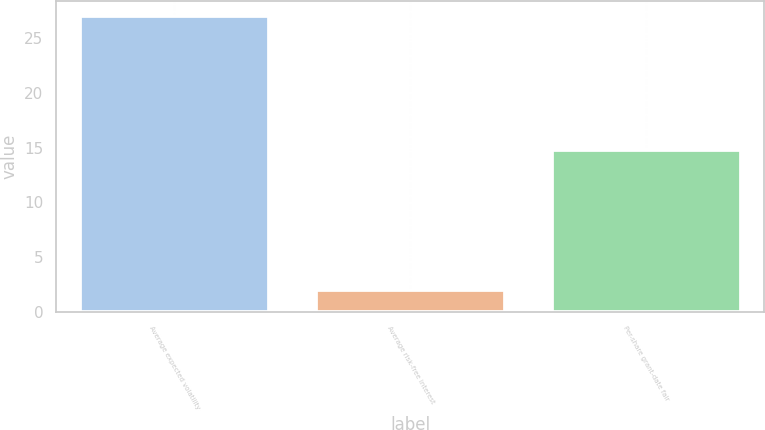Convert chart. <chart><loc_0><loc_0><loc_500><loc_500><bar_chart><fcel>Average expected volatility<fcel>Average risk-free interest<fcel>Per-share grant-date fair<nl><fcel>27<fcel>2<fcel>14.75<nl></chart> 